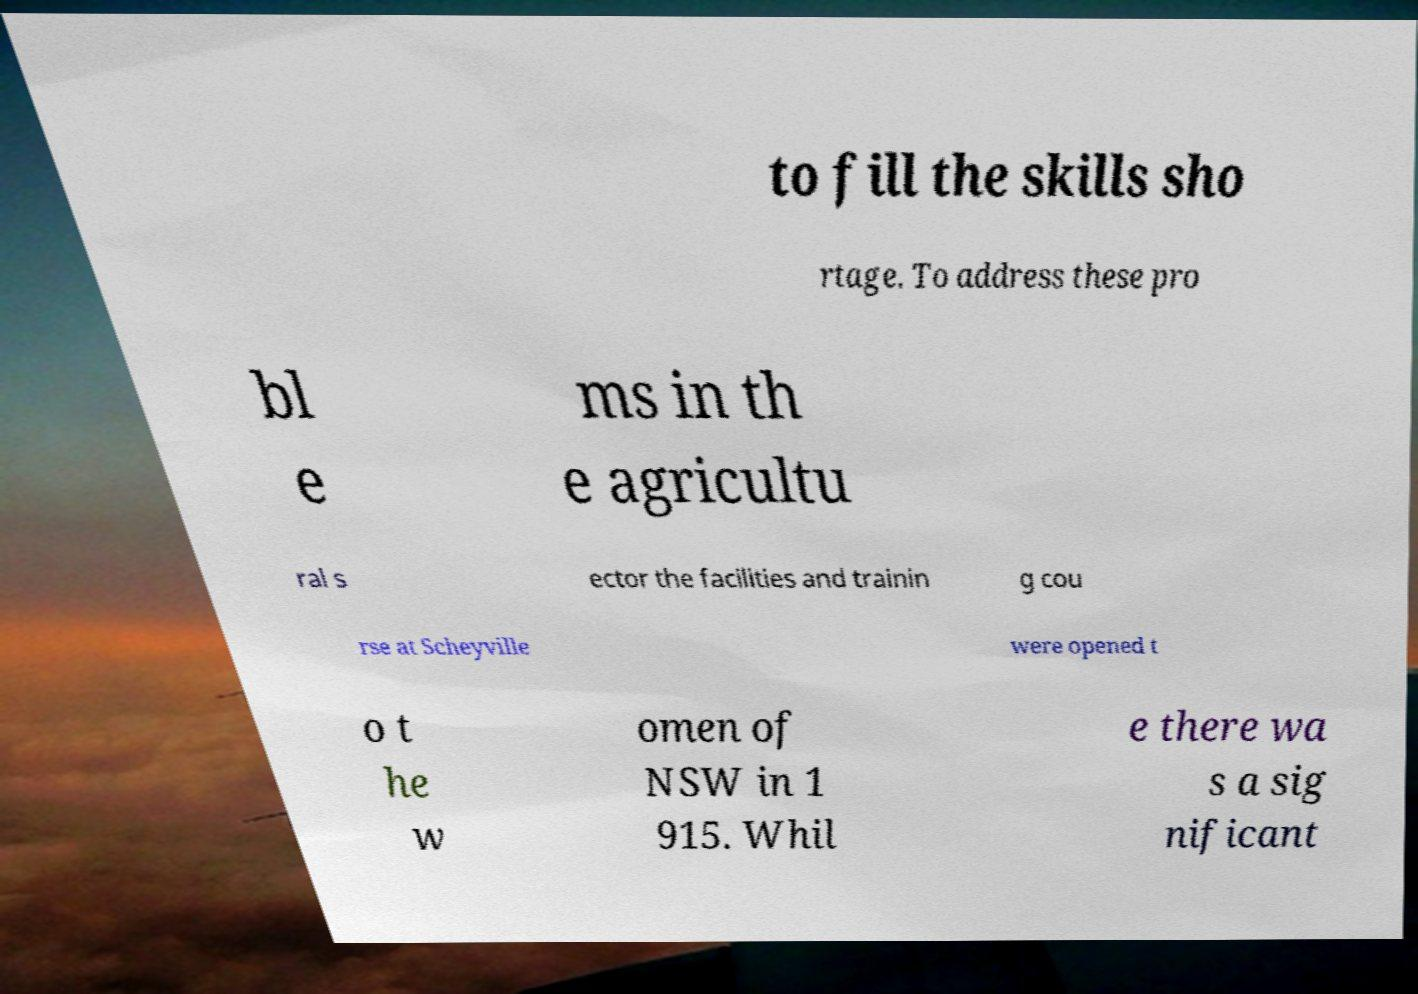Could you extract and type out the text from this image? to fill the skills sho rtage. To address these pro bl e ms in th e agricultu ral s ector the facilities and trainin g cou rse at Scheyville were opened t o t he w omen of NSW in 1 915. Whil e there wa s a sig nificant 